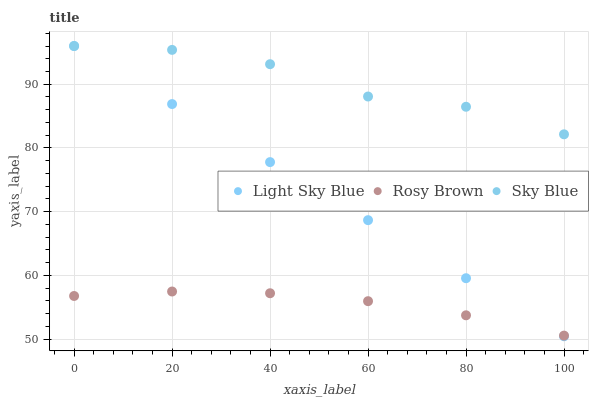Does Rosy Brown have the minimum area under the curve?
Answer yes or no. Yes. Does Sky Blue have the maximum area under the curve?
Answer yes or no. Yes. Does Light Sky Blue have the minimum area under the curve?
Answer yes or no. No. Does Light Sky Blue have the maximum area under the curve?
Answer yes or no. No. Is Light Sky Blue the smoothest?
Answer yes or no. Yes. Is Sky Blue the roughest?
Answer yes or no. Yes. Is Rosy Brown the smoothest?
Answer yes or no. No. Is Rosy Brown the roughest?
Answer yes or no. No. Does Light Sky Blue have the lowest value?
Answer yes or no. Yes. Does Rosy Brown have the lowest value?
Answer yes or no. No. Does Light Sky Blue have the highest value?
Answer yes or no. Yes. Does Rosy Brown have the highest value?
Answer yes or no. No. Is Rosy Brown less than Sky Blue?
Answer yes or no. Yes. Is Sky Blue greater than Rosy Brown?
Answer yes or no. Yes. Does Light Sky Blue intersect Rosy Brown?
Answer yes or no. Yes. Is Light Sky Blue less than Rosy Brown?
Answer yes or no. No. Is Light Sky Blue greater than Rosy Brown?
Answer yes or no. No. Does Rosy Brown intersect Sky Blue?
Answer yes or no. No. 